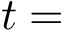<formula> <loc_0><loc_0><loc_500><loc_500>t =</formula> 